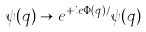<formula> <loc_0><loc_0><loc_500><loc_500>\psi ( { q ) } \to e ^ { + i e \Phi ( { q } ) / } \psi ( { q ) }</formula> 